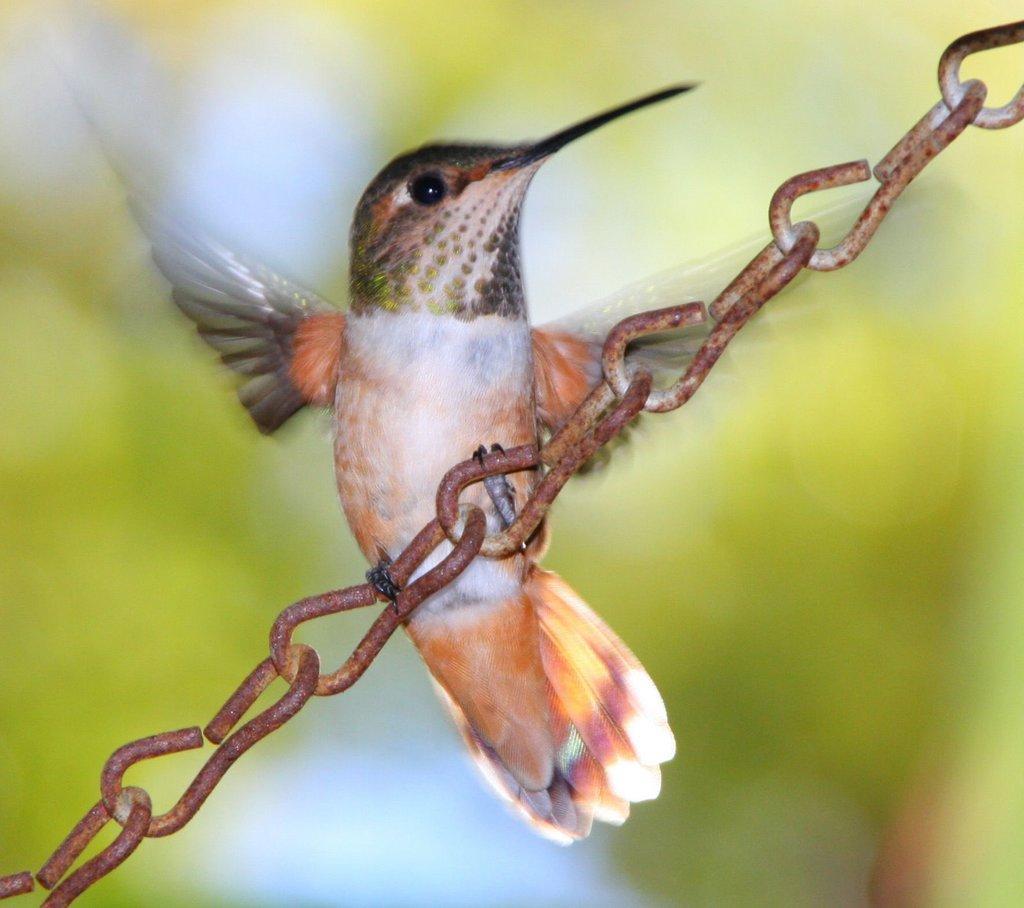Describe this image in one or two sentences. In the center of the image, we can see a bird on the chain and the background is blurry. 